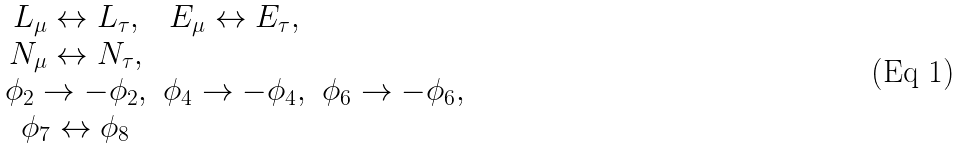Convert formula to latex. <formula><loc_0><loc_0><loc_500><loc_500>\begin{matrix} L _ { \mu } \leftrightarrow L _ { \tau } , & E _ { \mu } \leftrightarrow E _ { \tau } , \\ N _ { \mu } \leftrightarrow N _ { \tau } , & \\ \phi _ { 2 } \rightarrow - \phi _ { 2 } , & \phi _ { 4 } \rightarrow - \phi _ { 4 } , & \phi _ { 6 } \rightarrow - \phi _ { 6 } , \\ \phi _ { 7 } \leftrightarrow \phi _ { 8 } \end{matrix}</formula> 